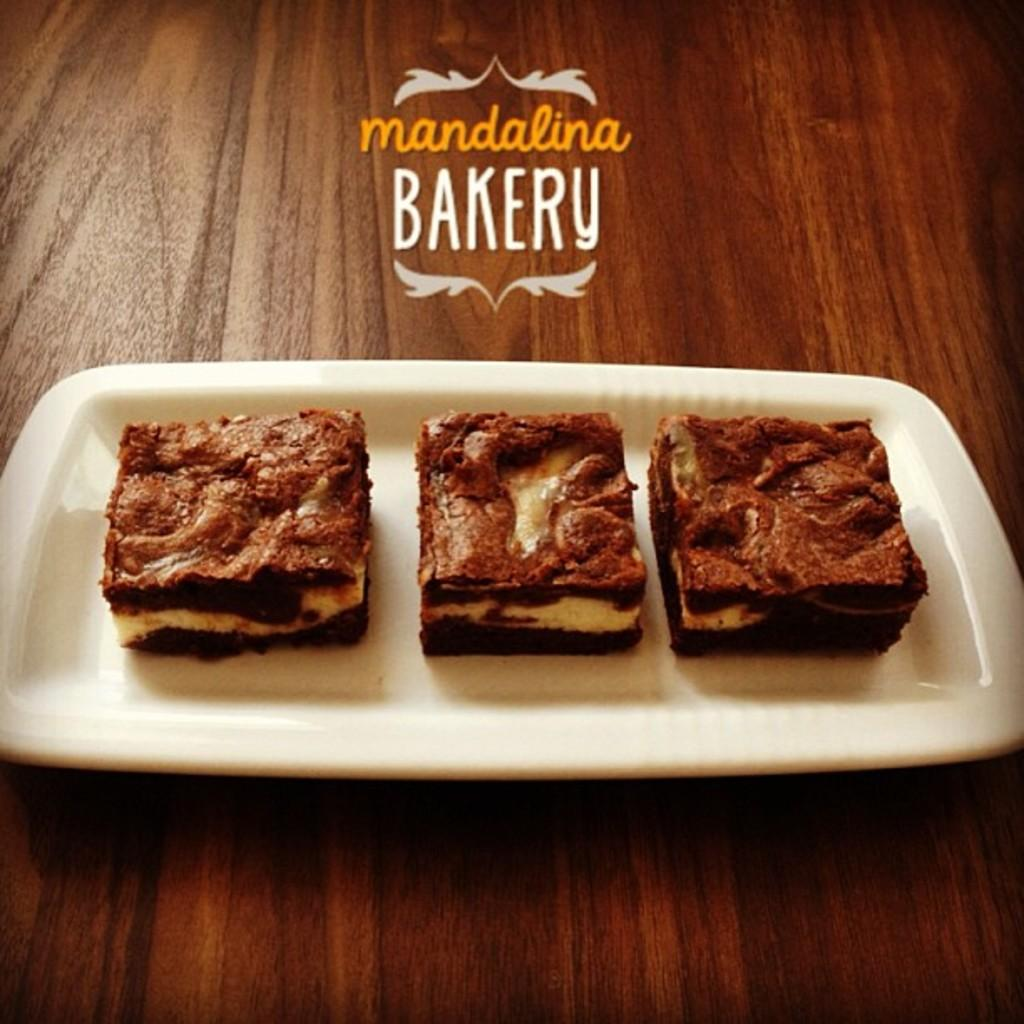How many cakes are visible in the image? There are three cakes in the image. How are the cakes arranged in the image? The cakes are arranged on a white color tray. What is the surface on which the tray is placed? The tray is placed on a wooden table. Can you describe any additional features of the image? There is a watermark at the top of the image. What type of toothpaste is used to decorate the cakes in the image? There is no toothpaste present in the image, and it is not used to decorate the cakes. Can you describe the flock of birds flying over the cakes in the image? There are no birds or flocks visible in the image; it only features three cakes on a tray. 